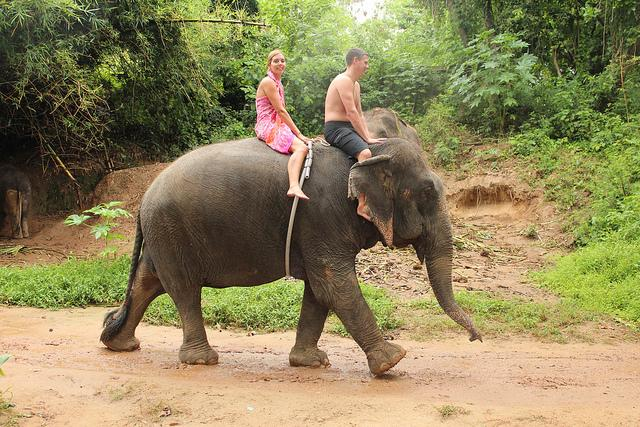What is the slowest thing that can move faster than the large thing here? human 